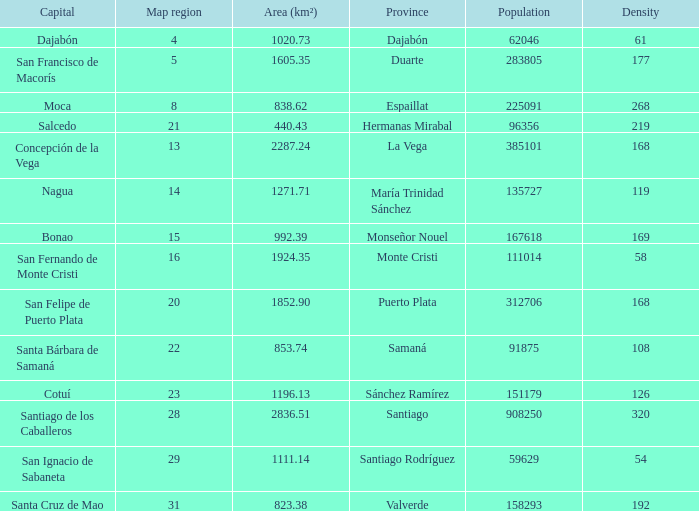Nagua has the area (km²) of? 1271.71. 